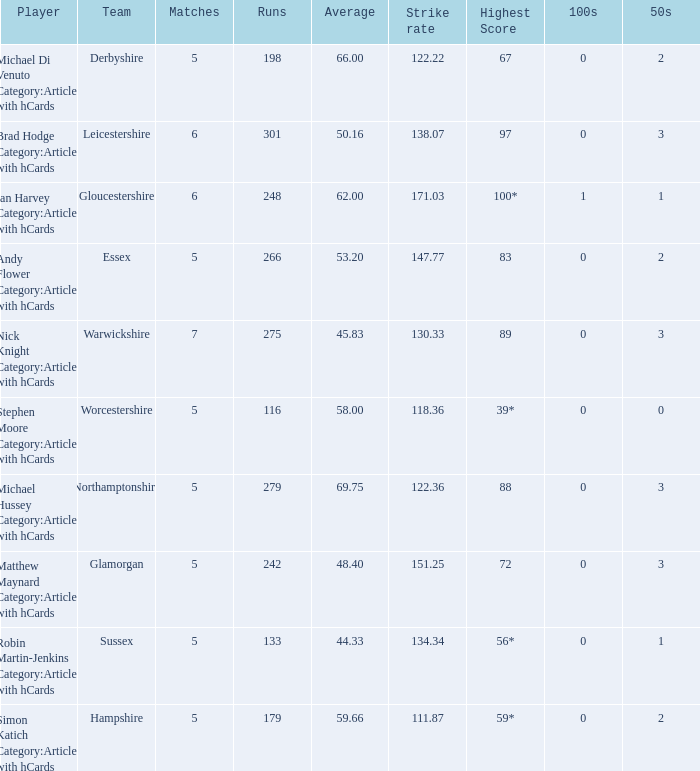If the team is Gloucestershire, what is the average? 62.0. 